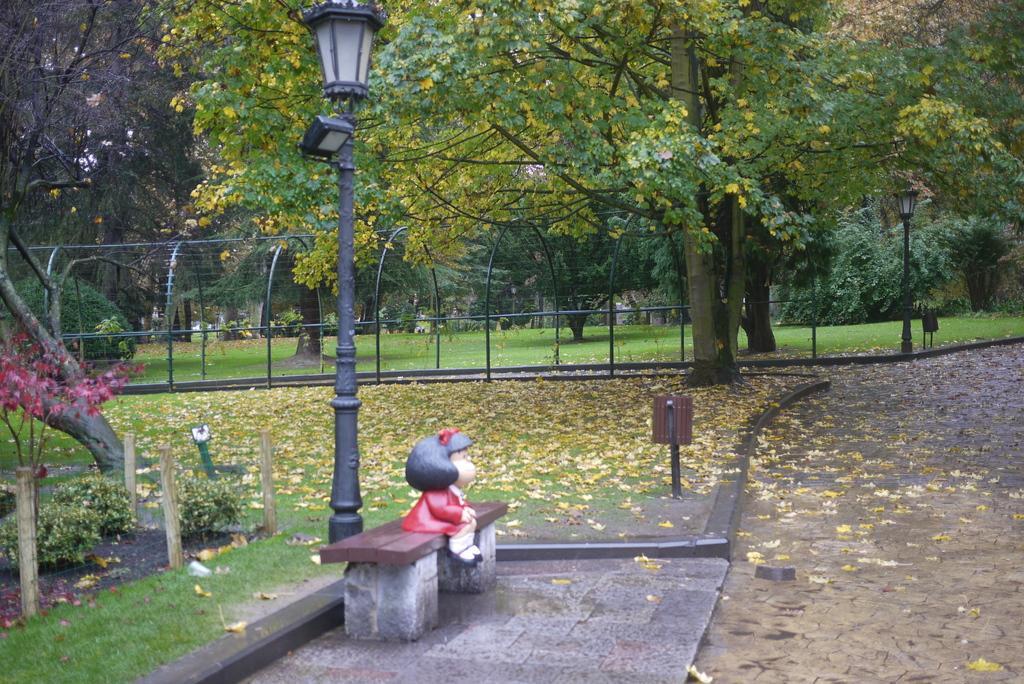In one or two sentences, can you explain what this image depicts? In the center of the image we can see a statue. In the background of the image we can see the trees, grass, dry leaves, plants, mesh, fence, board, poles, lights. At the bottom of the image we can see the road. 